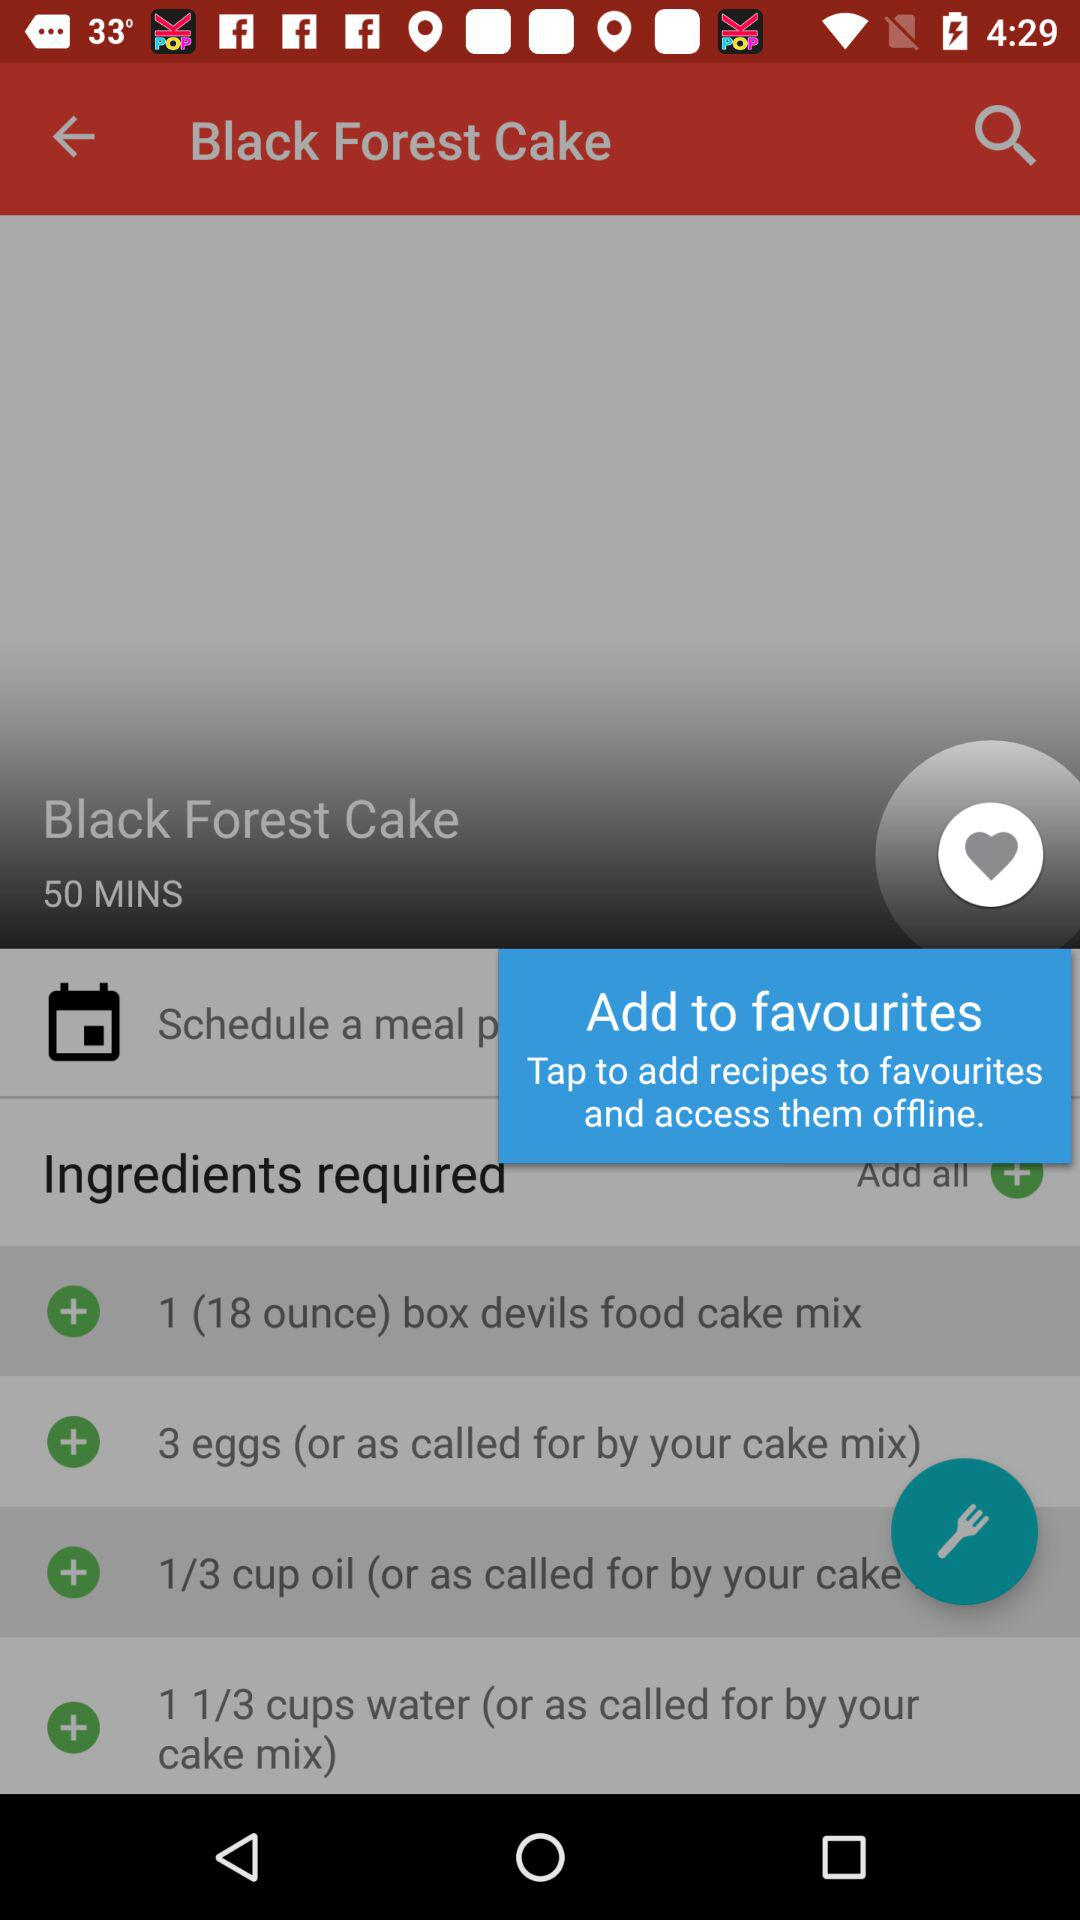How much oil is required? The required amount of oil is one third cup. 